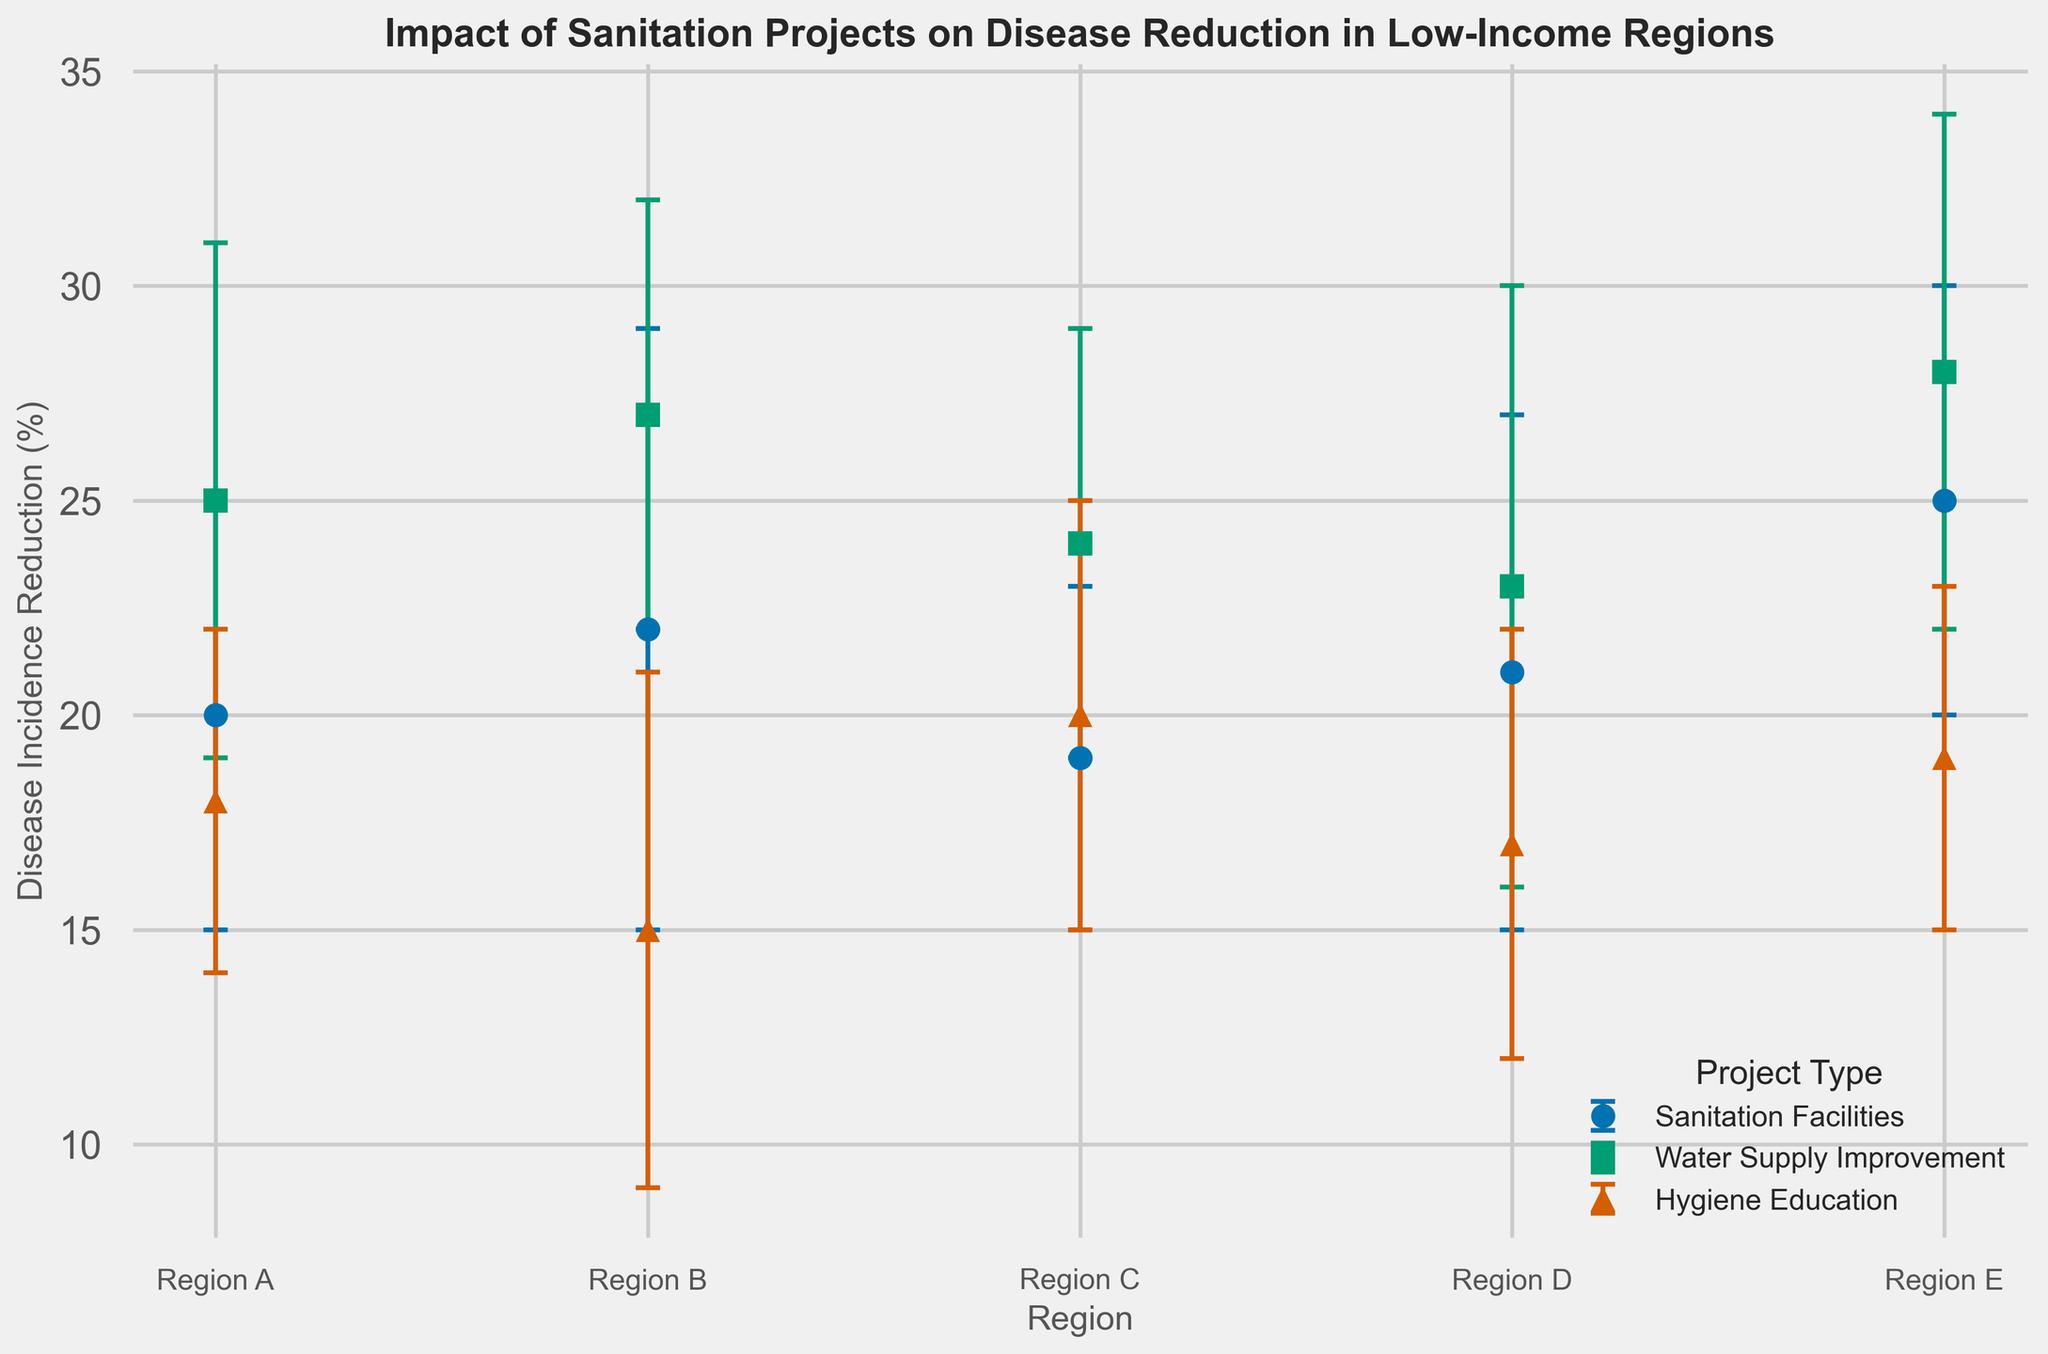what is the average disease incidence reduction for water supply improvement projects? Calculate the average by summing the disease incidence reduction percentages for water supply improvement projects in each region and then dividing by the number of regions: (25 + 27 + 24 + 23 + 28) / 5 = 127 / 5 = 25.4
Answer: 25.4 Which project type shows the highest reduction in disease incidence for Region B? Compare the disease incidence reduction percentages for the different project types in Region B. Sanitation Facilities: 22%, Water Supply Improvement: 27%, Hygiene Education: 15%. Water Supply Improvement has the highest reduction.
Answer: Water Supply Improvement What is the difference in disease incidence reduction between sanitation facilities and hygiene education projects in Region D? Subtract the disease incidence reduction percentage of Hygiene Education projects from that of Sanitation Facilities projects in Region D: 21% - 17% = 4%
Answer: 4% Which region shows the largest variability in outcomes for water supply improvement projects? Compare the error margins for water supply improvement projects across regions: Region A: 6%, Region B: 5%, Region C: 5%, Region D: 7%, Region E: 6%. Region D has the largest error margin (7%).
Answer: Region D What is the combined reduction in disease incidence from sanitation facilities across all regions? Sum the disease incidence reduction percentages for sanitation facilities in each region: 20 + 22 + 19 + 21 + 25 = 107
Answer: 107 Which project type has the most consistent outcome in terms of disease incidence reduction across regions, based on the error margins? Compare the error margins for each project type across regions to determine consistency. Sanitation Facilities: (5 + 7 + 4 + 6 + 5) / 5 = 5.4, Water Supply Improvement: (6 + 5 + 5 + 7 + 6) / 5 = 5.8, Hygiene Education: (4 + 6 + 5 + 5 + 4) / 5 = 4.8; Hygiene Education has the lowest average error margin, indicating the most consistent outcomes.
Answer: Hygiene Education 